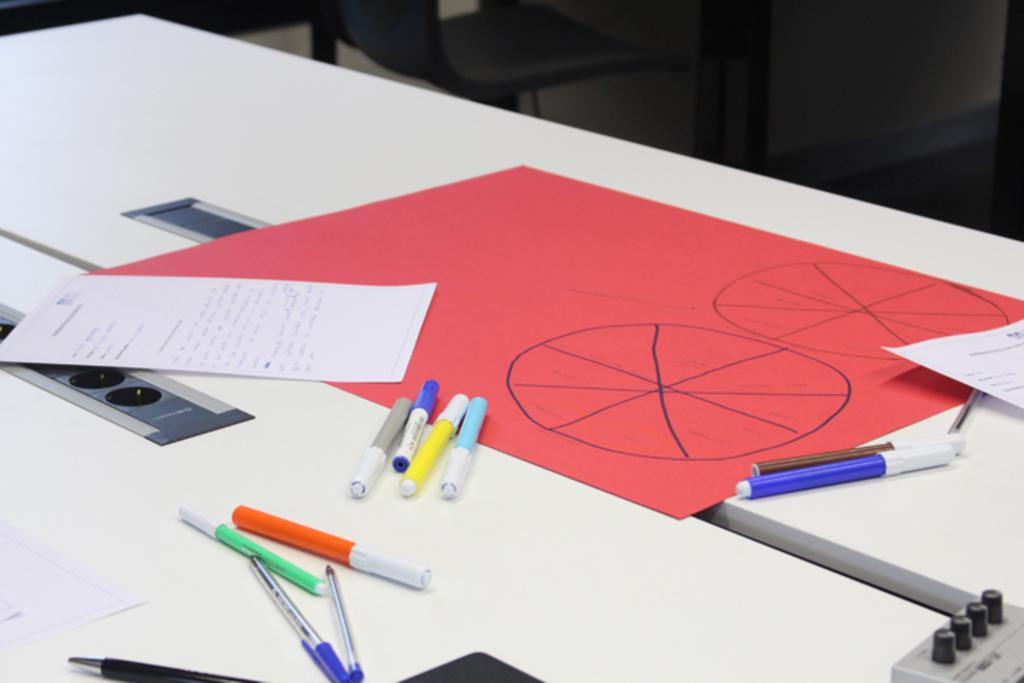What is the main piece of furniture in the image? There is a table in the image. What types of writing instruments are on the table? There are pens and markers on the table. What else is on the table besides writing instruments? There are papers, scales, and a red color chart on the table. Where are the buttons located in the image? The buttons are on the right side bottom of the image. Can you see an argument taking place between the pens and markers in the image? No, there is no argument taking place between the pens and markers in the image. Is there a knot tied on the table in the image? No, there is no knot present on the table in the image. 